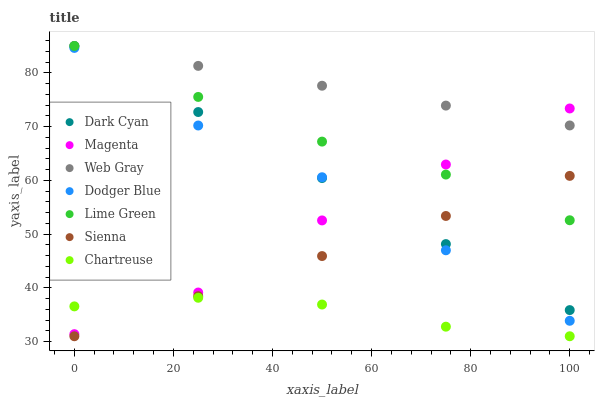Does Chartreuse have the minimum area under the curve?
Answer yes or no. Yes. Does Web Gray have the maximum area under the curve?
Answer yes or no. Yes. Does Sienna have the minimum area under the curve?
Answer yes or no. No. Does Sienna have the maximum area under the curve?
Answer yes or no. No. Is Sienna the smoothest?
Answer yes or no. Yes. Is Dodger Blue the roughest?
Answer yes or no. Yes. Is Chartreuse the smoothest?
Answer yes or no. No. Is Chartreuse the roughest?
Answer yes or no. No. Does Sienna have the lowest value?
Answer yes or no. Yes. Does Dodger Blue have the lowest value?
Answer yes or no. No. Does Lime Green have the highest value?
Answer yes or no. Yes. Does Sienna have the highest value?
Answer yes or no. No. Is Chartreuse less than Dodger Blue?
Answer yes or no. Yes. Is Web Gray greater than Sienna?
Answer yes or no. Yes. Does Web Gray intersect Lime Green?
Answer yes or no. Yes. Is Web Gray less than Lime Green?
Answer yes or no. No. Is Web Gray greater than Lime Green?
Answer yes or no. No. Does Chartreuse intersect Dodger Blue?
Answer yes or no. No. 